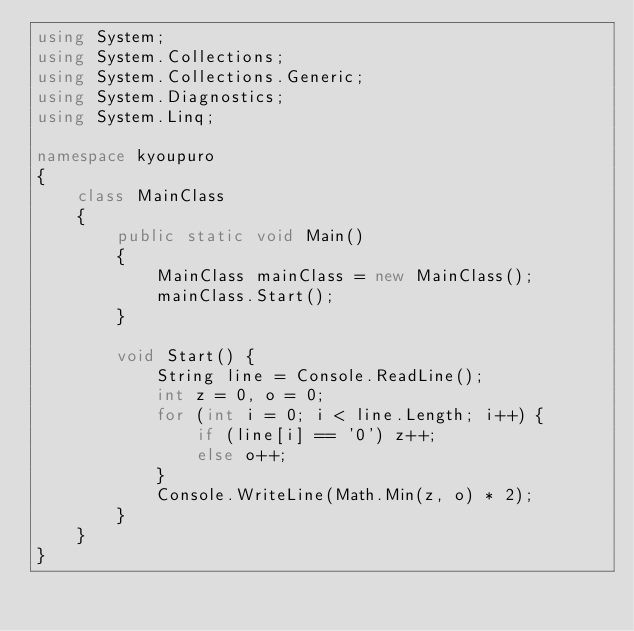<code> <loc_0><loc_0><loc_500><loc_500><_C#_>using System;
using System.Collections;
using System.Collections.Generic;
using System.Diagnostics;
using System.Linq;

namespace kyoupuro
{
    class MainClass
    {
        public static void Main()
        {
            MainClass mainClass = new MainClass();
            mainClass.Start();
        }

        void Start() {
            String line = Console.ReadLine();
            int z = 0, o = 0;
            for (int i = 0; i < line.Length; i++) {
                if (line[i] == '0') z++;
                else o++;
            }
            Console.WriteLine(Math.Min(z, o) * 2);
        }
    }
}
</code> 